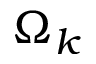<formula> <loc_0><loc_0><loc_500><loc_500>\Omega _ { k }</formula> 